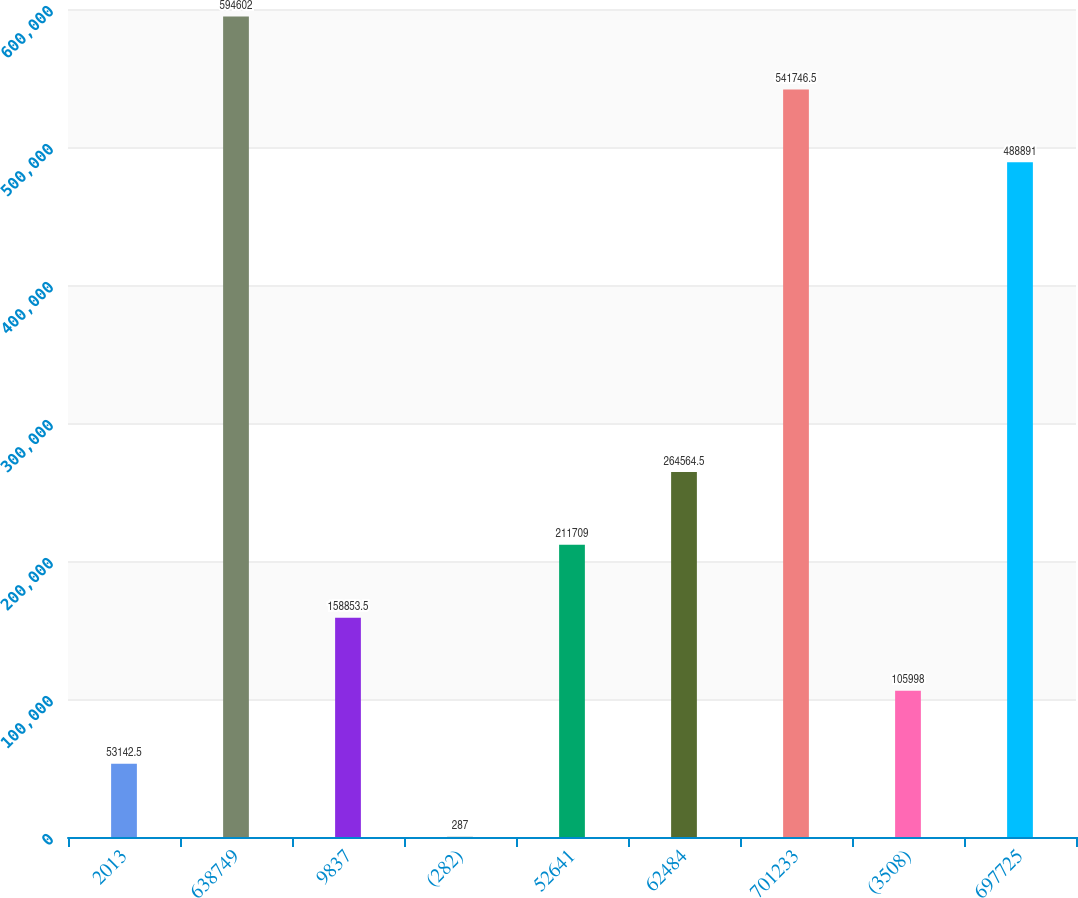Convert chart to OTSL. <chart><loc_0><loc_0><loc_500><loc_500><bar_chart><fcel>2013<fcel>638749<fcel>9837<fcel>(282)<fcel>52641<fcel>62484<fcel>701233<fcel>(3508)<fcel>697725<nl><fcel>53142.5<fcel>594602<fcel>158854<fcel>287<fcel>211709<fcel>264564<fcel>541746<fcel>105998<fcel>488891<nl></chart> 